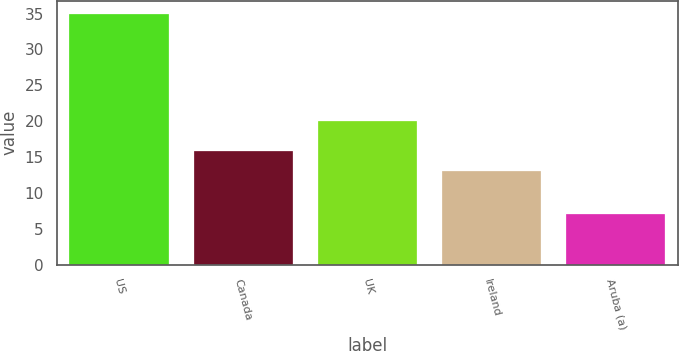<chart> <loc_0><loc_0><loc_500><loc_500><bar_chart><fcel>US<fcel>Canada<fcel>UK<fcel>Ireland<fcel>Aruba (a)<nl><fcel>35<fcel>15.8<fcel>20<fcel>13<fcel>7<nl></chart> 